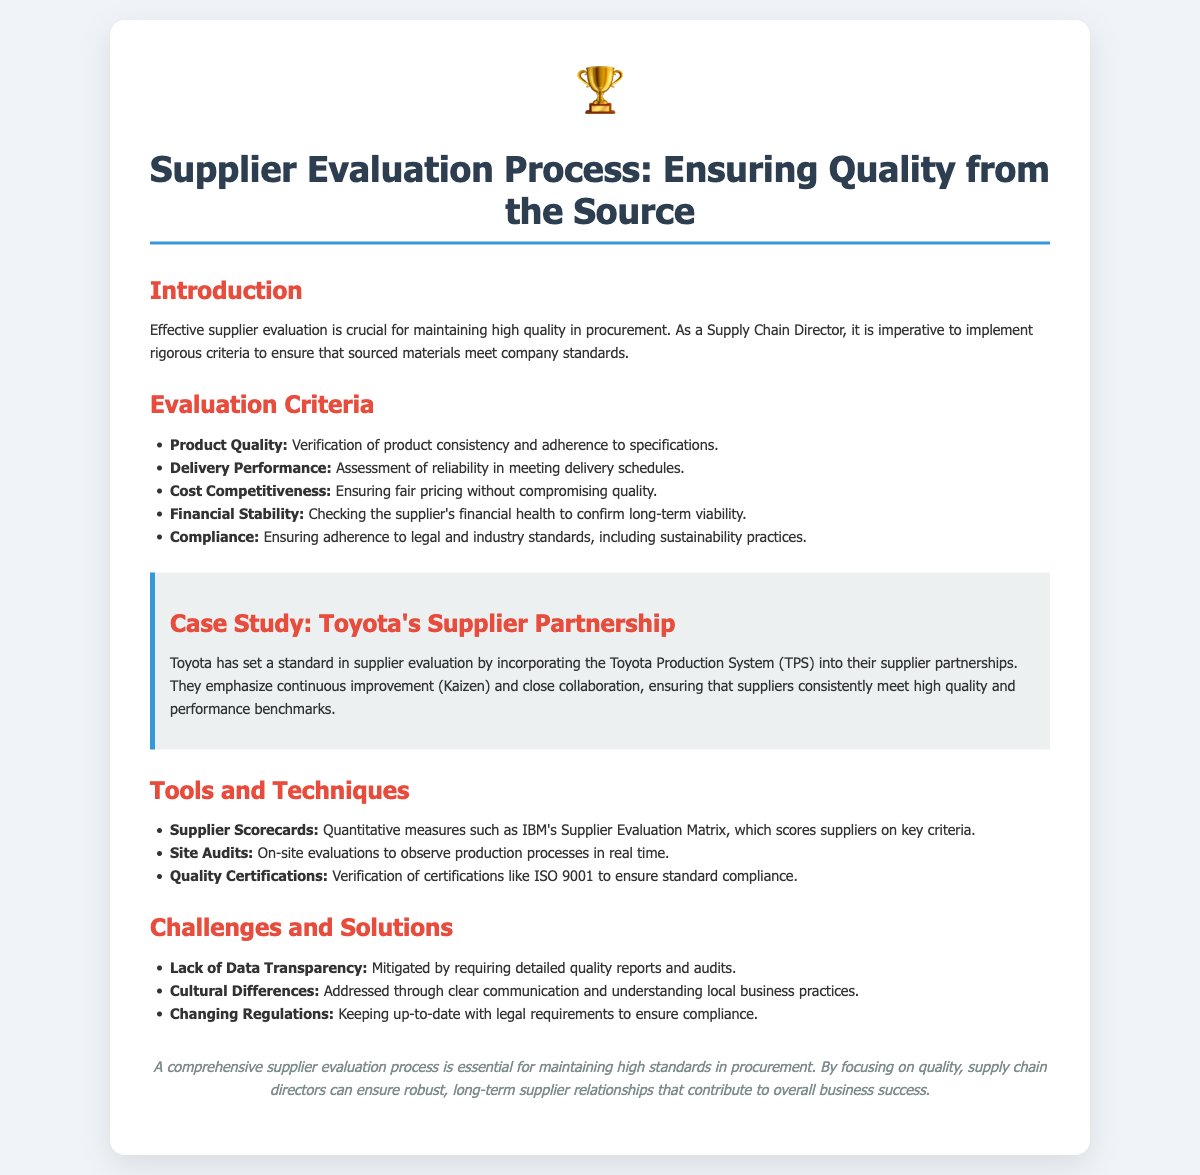what is the purpose of effective supplier evaluation? The document states that effective supplier evaluation is crucial for maintaining high quality in procurement.
Answer: maintaining high quality name one evaluation criterion mentioned in the document. The section on Evaluation Criteria lists several criteria, one of which is Product Quality.
Answer: Product Quality which company is highlighted in the case study? The case study discusses the practices of Toyota in relation to supplier partnerships.
Answer: Toyota what percentage of the supplier scorecards is quantitative? The document refers to the Supplier Scorecards as quantitative measures, but does not specify a percentage.
Answer: Not specified what is the primary focus of a comprehensive supplier evaluation process? The conclusion states that a comprehensive supplier evaluation process is essential for maintaining high standards in procurement.
Answer: high standards list one tool mentioned for supplier evaluation. The section on Tools and Techniques lists Supplier Scorecards among other tools.
Answer: Supplier Scorecards which method does Toyota emphasize in its supplier partnerships? The case study notes that Toyota emphasizes continuous improvement, also known as Kaizen, in its supplier partnerships.
Answer: Kaizen identify one challenge mentioned in the document. The Challenges and Solutions section lists Lack of Data Transparency as one of the challenges faced.
Answer: Lack of Data Transparency 